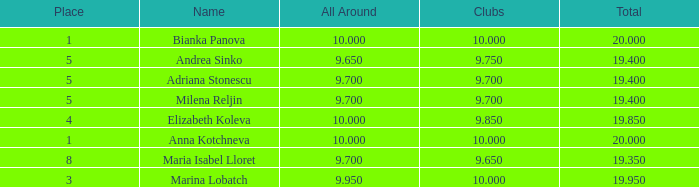What are the lowest clubs that have a place greater than 5, with an all around greater than 9.7? None. 